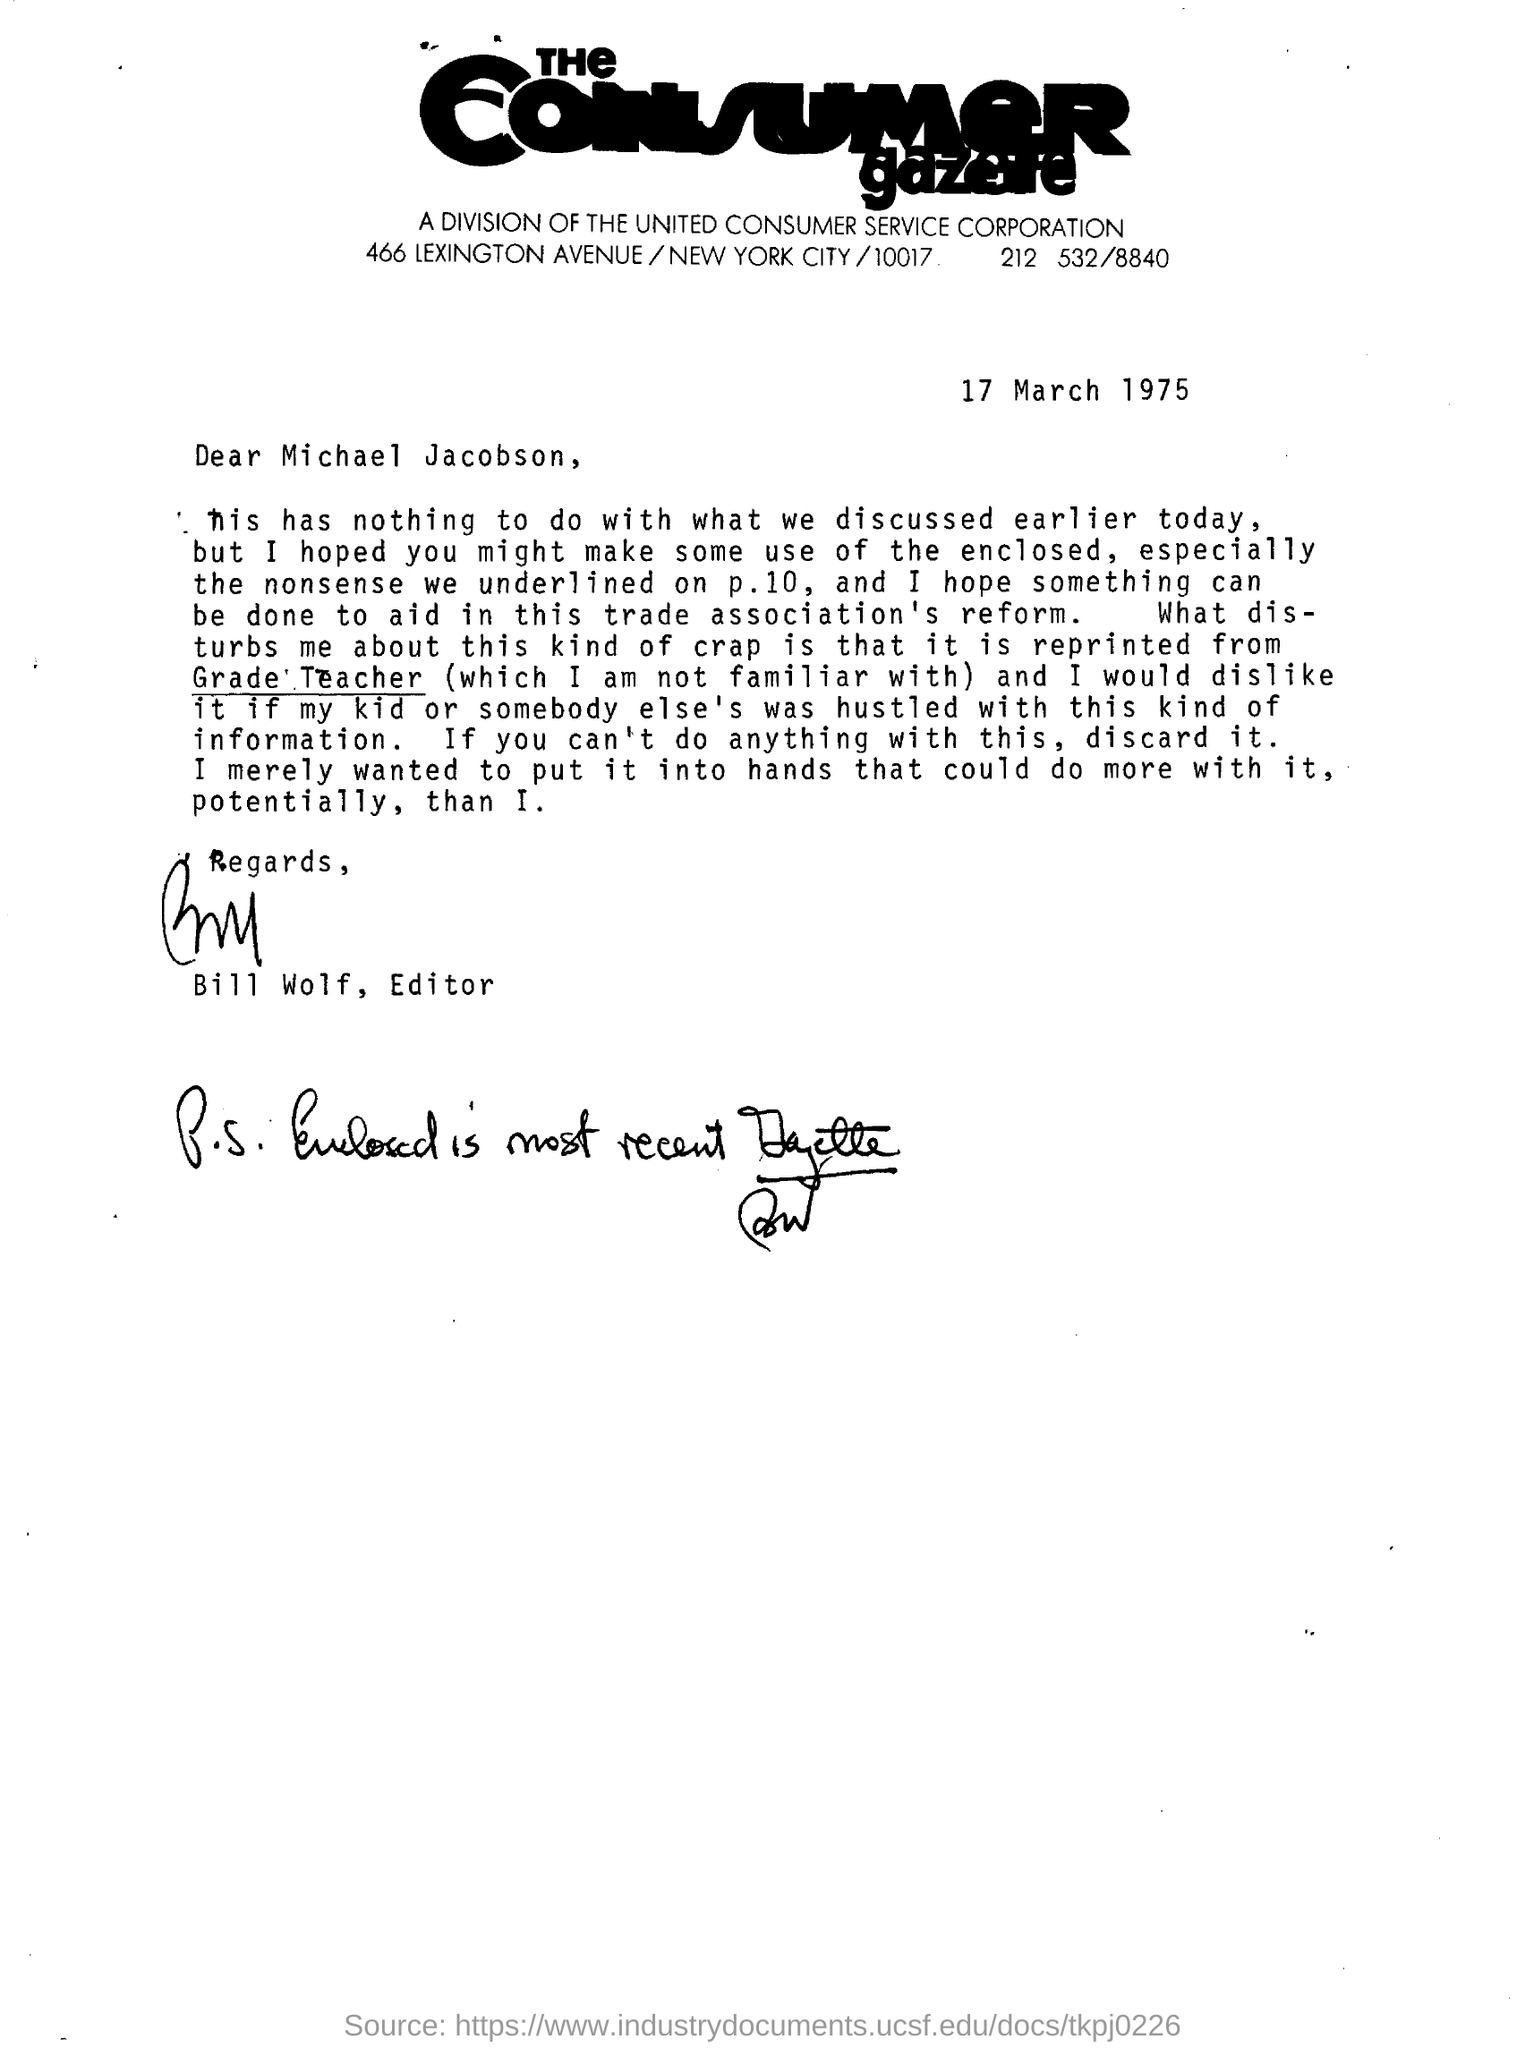This letter was written to whom?
Give a very brief answer. Michael jacobson. On  which date was  this letter was written
Ensure brevity in your answer.  17 march 1975. Who is the editor who signed this letter?
Ensure brevity in your answer.  Bill Wolf. Under which corporation this letter has been written
Give a very brief answer. The United Consumer Service Corporation. 